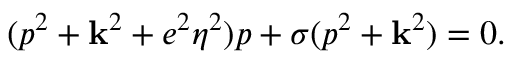Convert formula to latex. <formula><loc_0><loc_0><loc_500><loc_500>( p ^ { 2 } + { k } ^ { 2 } + e ^ { 2 } \eta ^ { 2 } ) p + \sigma ( p ^ { 2 } + { k } ^ { 2 } ) = 0 .</formula> 